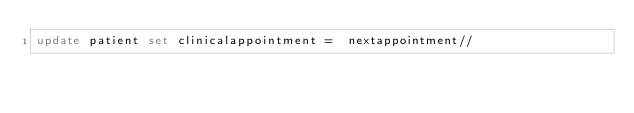Convert code to text. <code><loc_0><loc_0><loc_500><loc_500><_SQL_>update patient set clinicalappointment =  nextappointment//</code> 